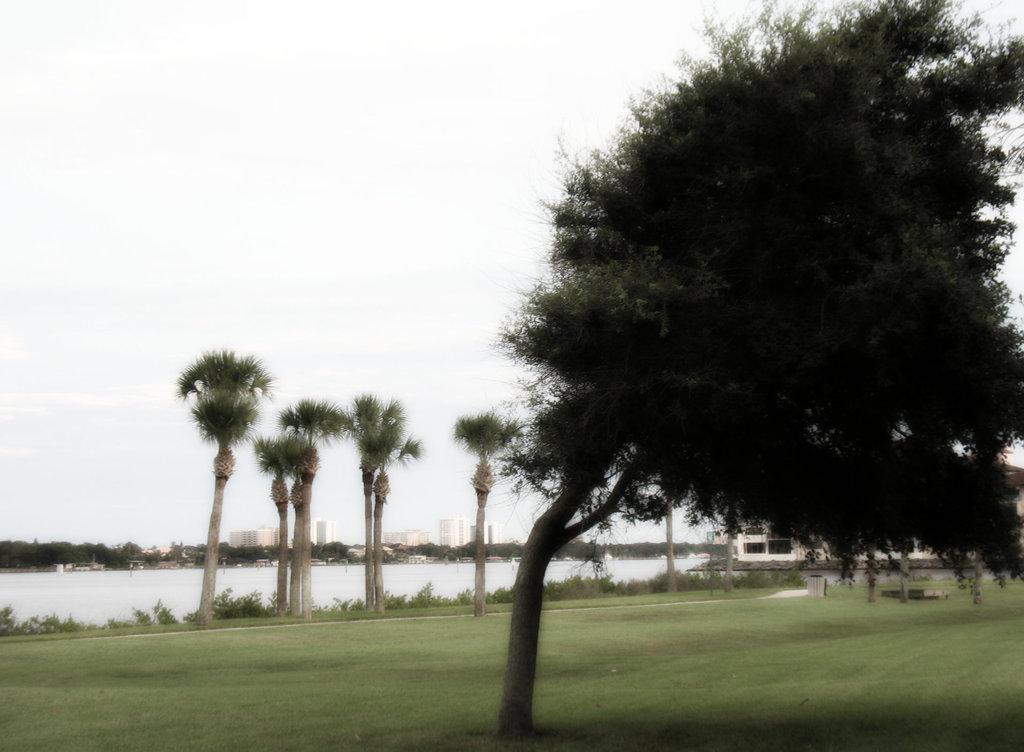Can you describe this image briefly? In this image I can see few trees, the ground, some grass and a building. In the background I can see the water, few trees, few buildings and the sky. 